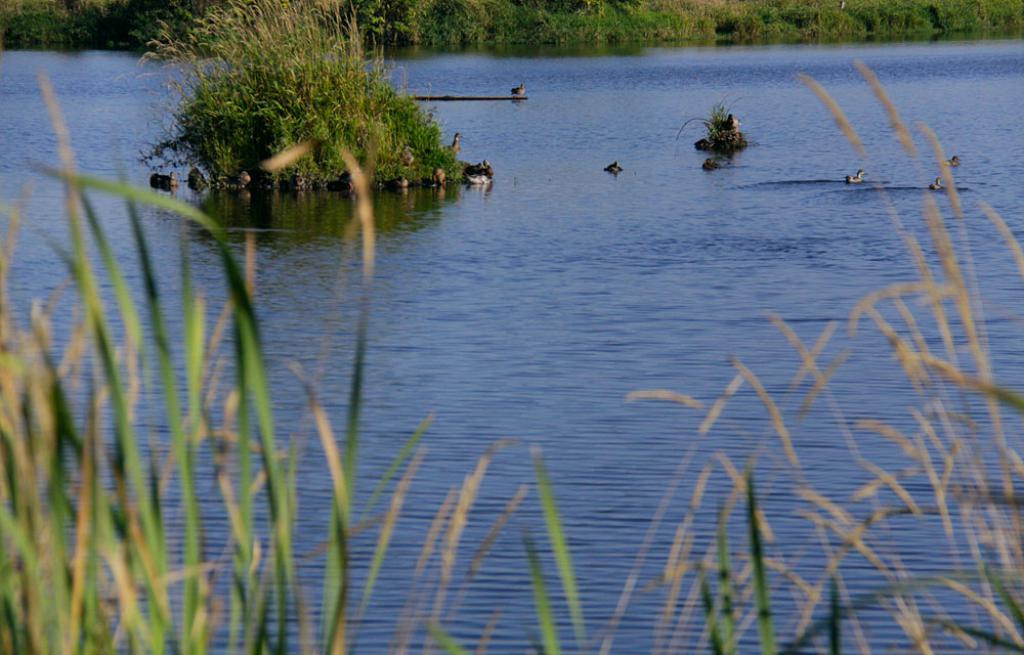What type of animals can be seen in the image? There is a group of birds in the image. Where are the birds located in the image? The birds are in a large water body and on stones. What other natural elements can be seen in the image? There is a group of plants visible in the image. What type of brake system can be seen on the birds in the image? There is no brake system present on the birds in the image, as birds do not have brake systems. 